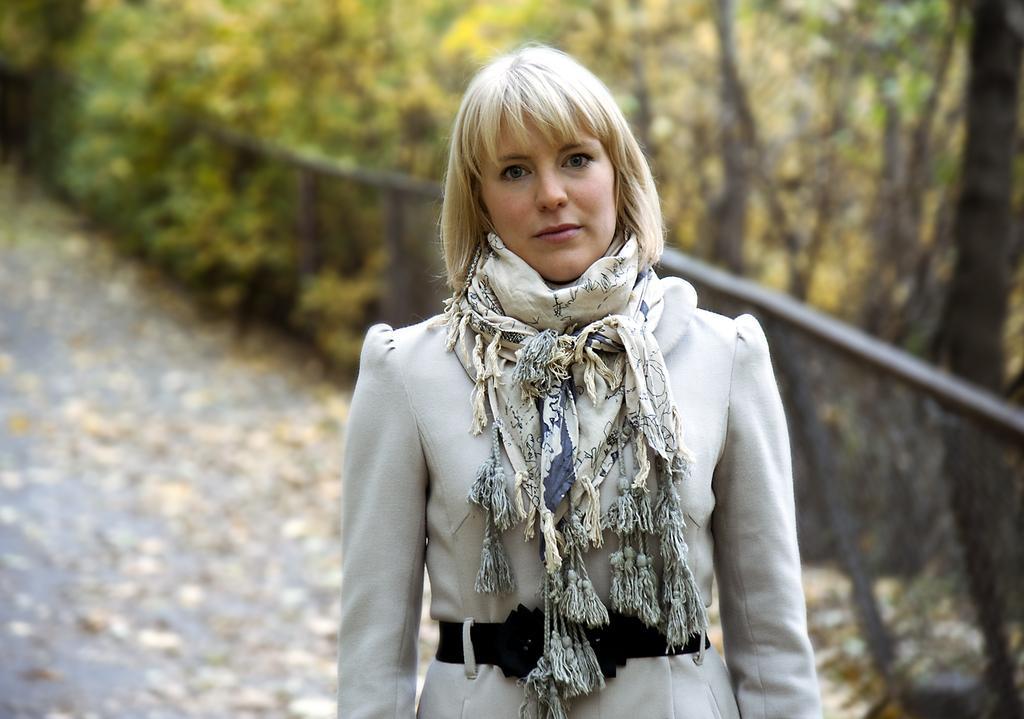Describe this image in one or two sentences. In this picture I can see a woman standing and wearing a scarf. I can see trees. I can see fencing. 